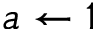<formula> <loc_0><loc_0><loc_500><loc_500>a \gets 1</formula> 